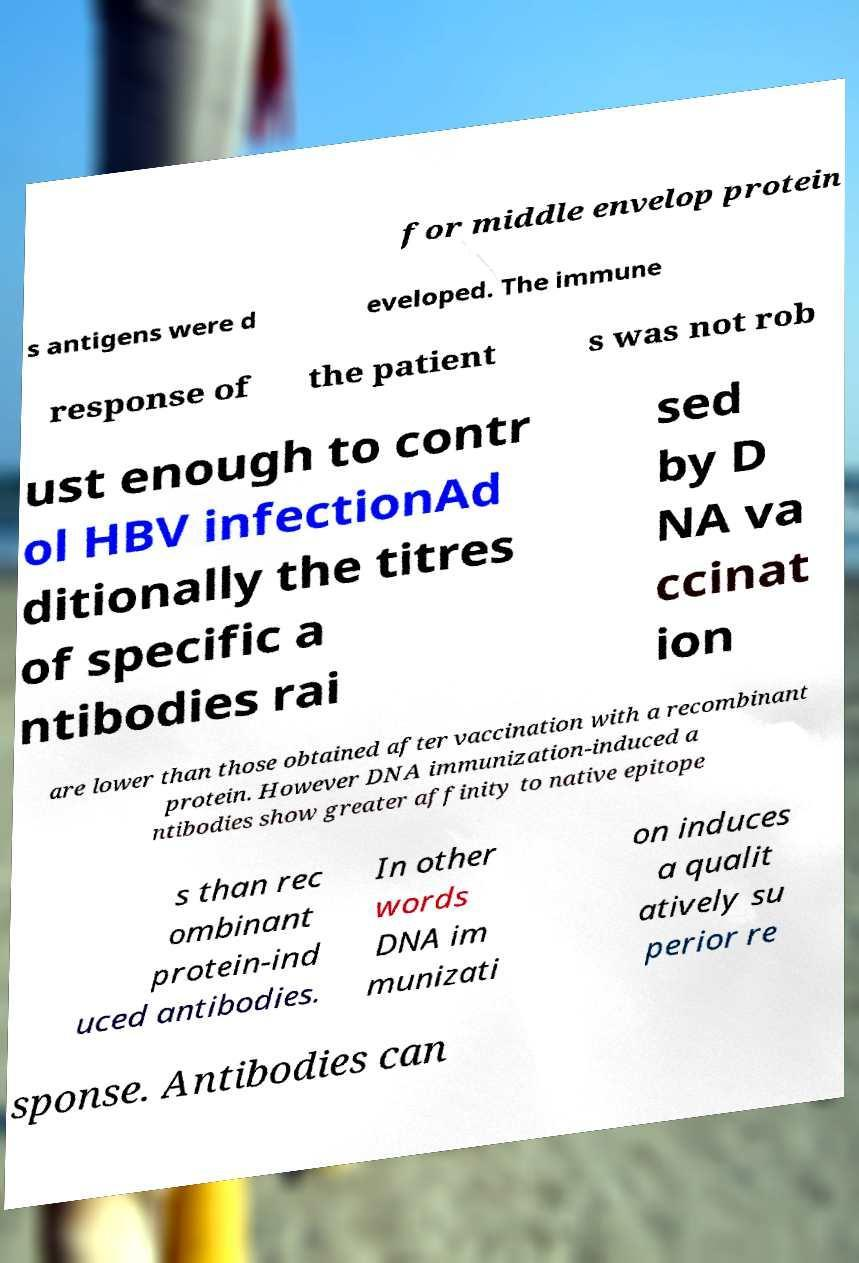Can you read and provide the text displayed in the image?This photo seems to have some interesting text. Can you extract and type it out for me? for middle envelop protein s antigens were d eveloped. The immune response of the patient s was not rob ust enough to contr ol HBV infectionAd ditionally the titres of specific a ntibodies rai sed by D NA va ccinat ion are lower than those obtained after vaccination with a recombinant protein. However DNA immunization-induced a ntibodies show greater affinity to native epitope s than rec ombinant protein-ind uced antibodies. In other words DNA im munizati on induces a qualit atively su perior re sponse. Antibodies can 